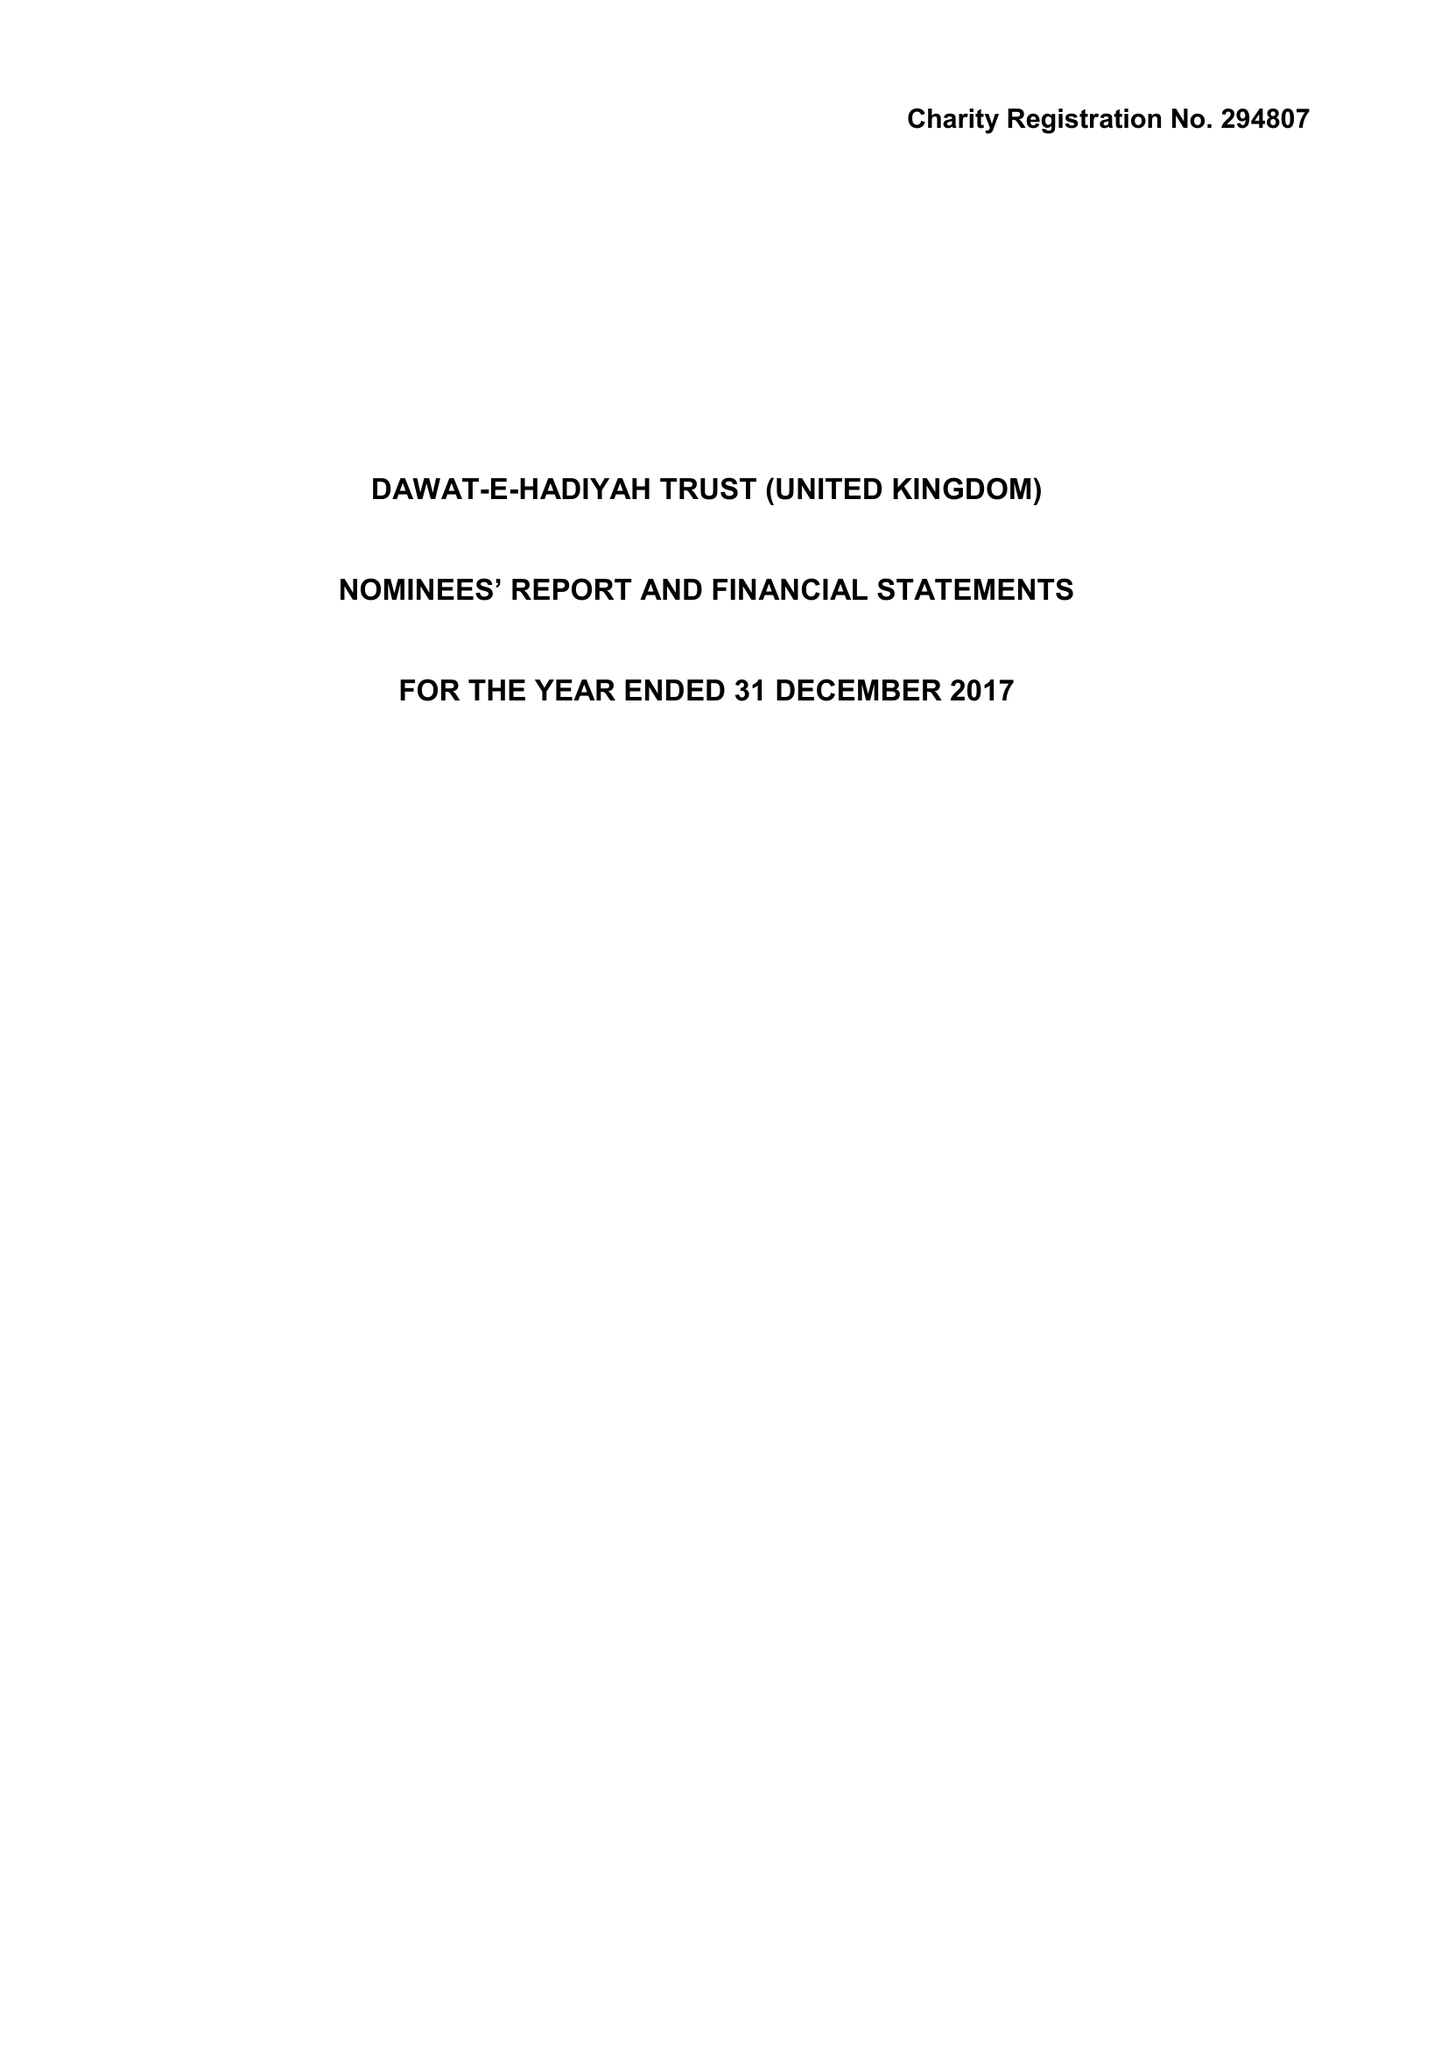What is the value for the charity_name?
Answer the question using a single word or phrase. Dawat-E-Hadiyah Trust (United Kingdom) 